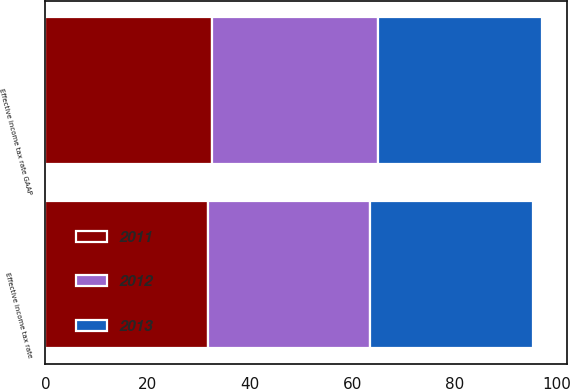<chart> <loc_0><loc_0><loc_500><loc_500><stacked_bar_chart><ecel><fcel>Effective income tax rate GAAP<fcel>Effective income tax rate<nl><fcel>2012<fcel>32.4<fcel>31.7<nl><fcel>2013<fcel>32.1<fcel>31.8<nl><fcel>2011<fcel>32.6<fcel>31.8<nl></chart> 